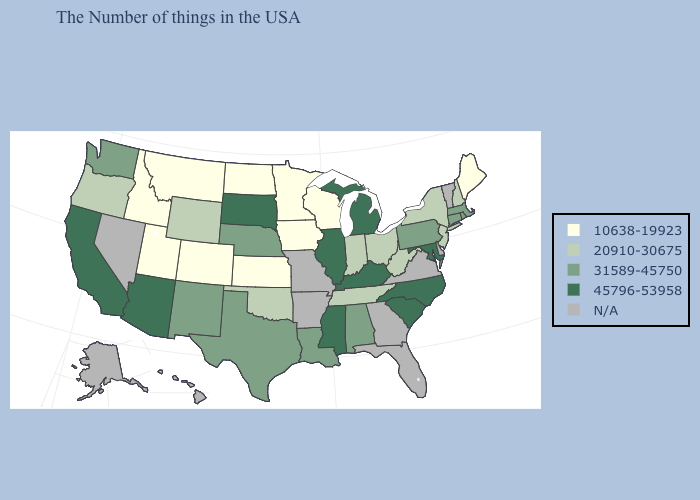What is the value of Nebraska?
Keep it brief. 31589-45750. What is the lowest value in the USA?
Concise answer only. 10638-19923. Which states have the lowest value in the MidWest?
Answer briefly. Wisconsin, Minnesota, Iowa, Kansas, North Dakota. Which states have the lowest value in the Northeast?
Concise answer only. Maine. Does Michigan have the highest value in the USA?
Write a very short answer. Yes. Name the states that have a value in the range 20910-30675?
Write a very short answer. New Hampshire, New York, New Jersey, West Virginia, Ohio, Indiana, Tennessee, Oklahoma, Wyoming, Oregon. What is the highest value in states that border Delaware?
Answer briefly. 45796-53958. Which states have the highest value in the USA?
Short answer required. Maryland, North Carolina, South Carolina, Michigan, Kentucky, Illinois, Mississippi, South Dakota, Arizona, California. What is the value of Idaho?
Keep it brief. 10638-19923. Does Idaho have the lowest value in the USA?
Keep it brief. Yes. Which states have the lowest value in the USA?
Answer briefly. Maine, Wisconsin, Minnesota, Iowa, Kansas, North Dakota, Colorado, Utah, Montana, Idaho. What is the value of Georgia?
Write a very short answer. N/A. Name the states that have a value in the range 31589-45750?
Short answer required. Massachusetts, Rhode Island, Connecticut, Pennsylvania, Alabama, Louisiana, Nebraska, Texas, New Mexico, Washington. Which states hav the highest value in the West?
Write a very short answer. Arizona, California. What is the value of Massachusetts?
Keep it brief. 31589-45750. 